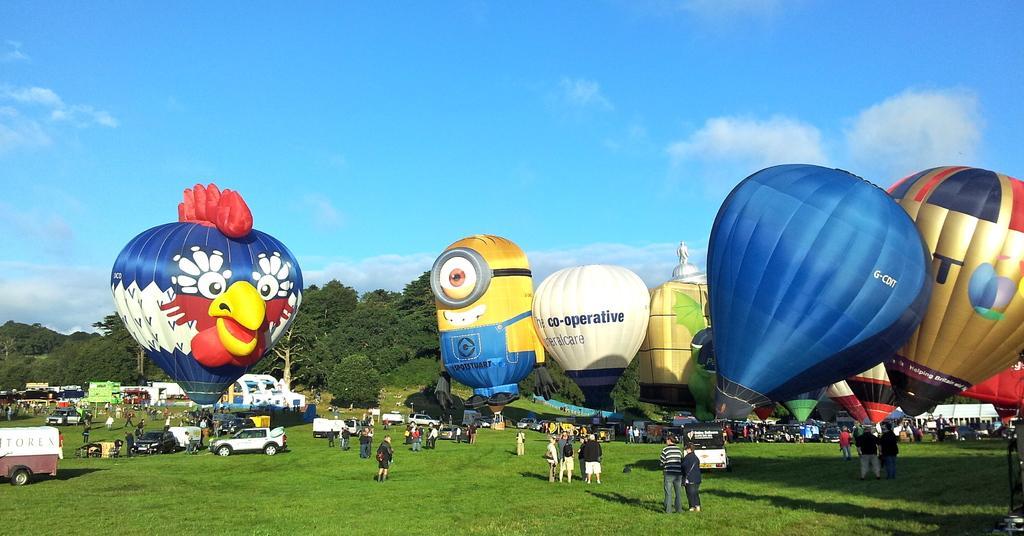In one or two sentences, can you explain what this image depicts? This picture is clicked outside. In the foreground we can see the group of persons and group of vehicles and there are some objects placed on the ground, the ground is covered with the green grass. In the center we can see there are many number of parachutes and we can see the text and some pictures on the parachute. In the background we can see the sky and the trees. 